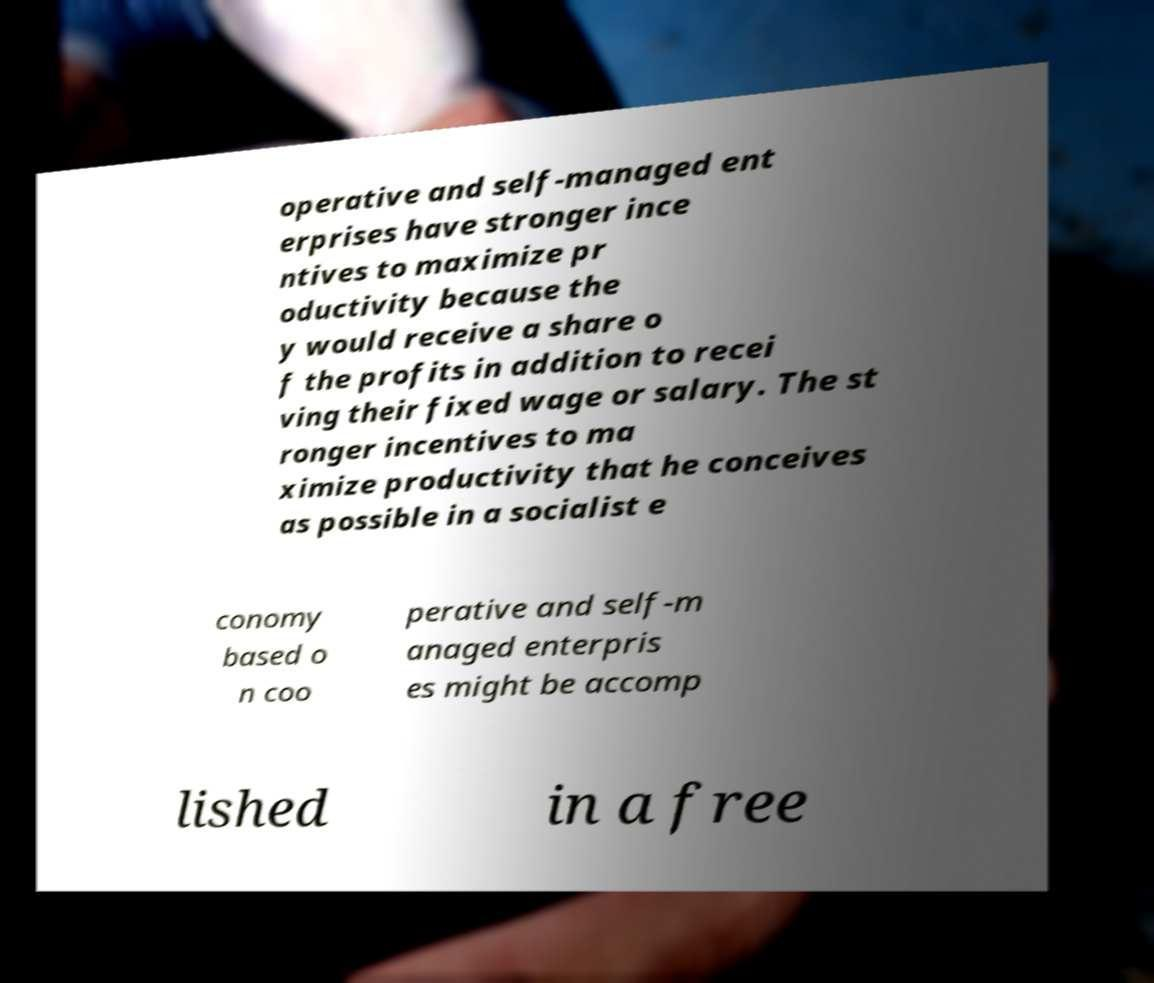There's text embedded in this image that I need extracted. Can you transcribe it verbatim? operative and self-managed ent erprises have stronger ince ntives to maximize pr oductivity because the y would receive a share o f the profits in addition to recei ving their fixed wage or salary. The st ronger incentives to ma ximize productivity that he conceives as possible in a socialist e conomy based o n coo perative and self-m anaged enterpris es might be accomp lished in a free 